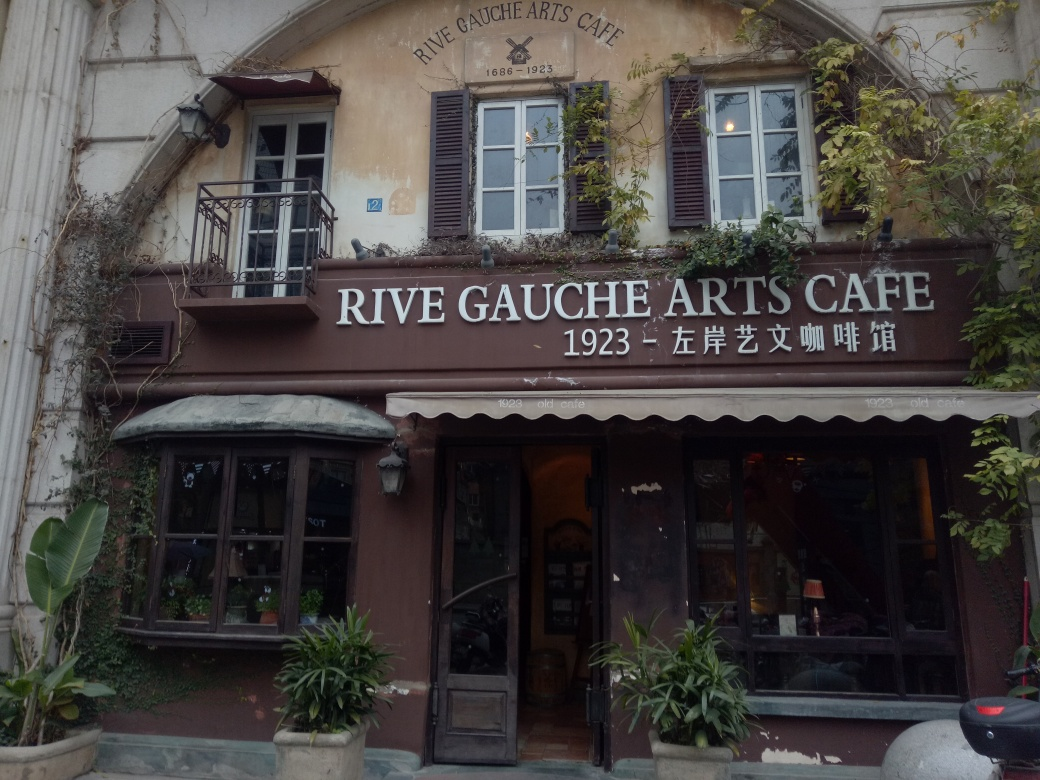How is the lighting in the image? The lighting in the image appears to be quite even, with no harsh shadows or overly bright areas disrupting the view of the Rive Gauche Arts Café. It provides a clear and comfortable visibility of the café's exterior and its charming details, contributing to the warm and inviting ambiance of the scene. 